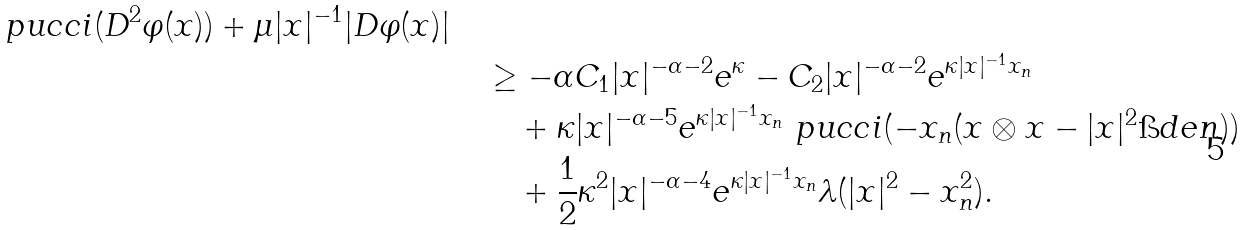Convert formula to latex. <formula><loc_0><loc_0><loc_500><loc_500>{ \ p u c c i ( D ^ { 2 } \varphi ( x ) ) + \mu | x | ^ { - 1 } | D \varphi ( x ) | } \quad & \\ & \geq - \alpha C _ { 1 } | x | ^ { - \alpha - 2 } e ^ { \kappa } - C _ { 2 } | x | ^ { - \alpha - 2 } e ^ { \kappa | x | ^ { - 1 } x _ { n } } \\ & \quad + \kappa | x | ^ { - \alpha - 5 } e ^ { \kappa | x | ^ { - 1 } x _ { n } } \ p u c c i ( - x _ { n } ( x \otimes x - | x | ^ { 2 } \i d e n ) ) \\ & \quad + \frac { 1 } { 2 } \kappa ^ { 2 } | x | ^ { - \alpha - 4 } e ^ { \kappa | x | ^ { - 1 } x _ { n } } \lambda ( | x | ^ { 2 } - x _ { n } ^ { 2 } ) .</formula> 